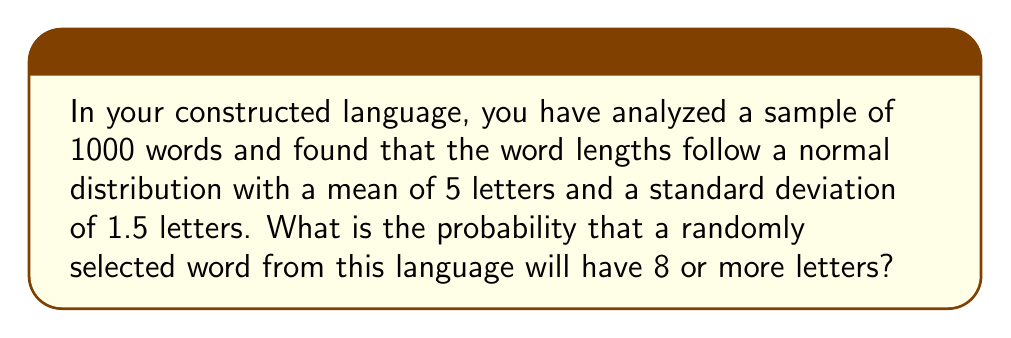Teach me how to tackle this problem. To solve this problem, we need to use the properties of the normal distribution and the concept of z-scores. Let's follow these steps:

1. Identify the given information:
   - Mean (μ) = 5 letters
   - Standard deviation (σ) = 1.5 letters
   - We want to find P(X ≥ 8), where X is the word length

2. Calculate the z-score for X = 8:
   $$ z = \frac{X - \mu}{\sigma} = \frac{8 - 5}{1.5} = 2 $$

3. Use the standard normal distribution table or a calculator to find the area to the right of z = 2:
   P(Z > 2) ≈ 0.0228

4. Therefore, the probability of a word having 8 or more letters is approximately 0.0228 or 2.28%

Note: This calculation assumes that word lengths can be treated as continuous variables, which is an approximation since actual word lengths are discrete. However, for the purposes of this problem and given the relatively large standard deviation, this approximation is reasonable.
Answer: 0.0228 